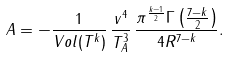<formula> <loc_0><loc_0><loc_500><loc_500>A = - \frac { 1 } { V o l ( T ^ { k } ) } \, \frac { v ^ { 4 } } { T _ { A } ^ { 3 } } \, \frac { \pi ^ { \frac { k - 1 } { 2 } } \Gamma \left ( \frac { 7 - k } { 2 } \right ) } { 4 R ^ { 7 - k } } .</formula> 